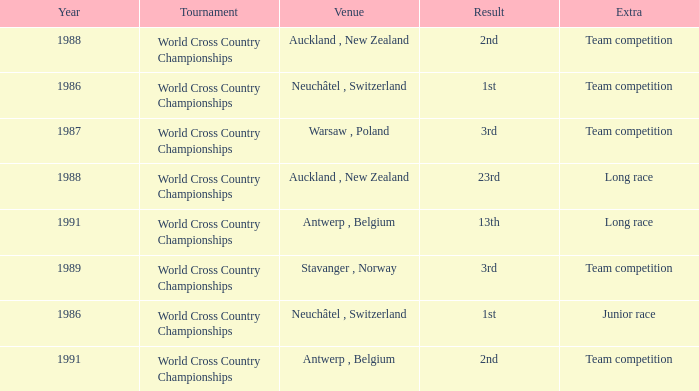Which venue led to a result of 23rd? Auckland , New Zealand. 